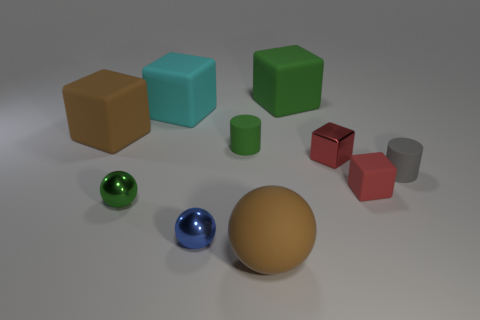Subtract all green blocks. How many blocks are left? 4 Subtract all small red metallic cubes. How many cubes are left? 4 Subtract all blue blocks. Subtract all yellow spheres. How many blocks are left? 5 Subtract all cylinders. How many objects are left? 8 Subtract 0 blue cubes. How many objects are left? 10 Subtract all big rubber cubes. Subtract all blue things. How many objects are left? 6 Add 2 small matte cubes. How many small matte cubes are left? 3 Add 5 blue blocks. How many blue blocks exist? 5 